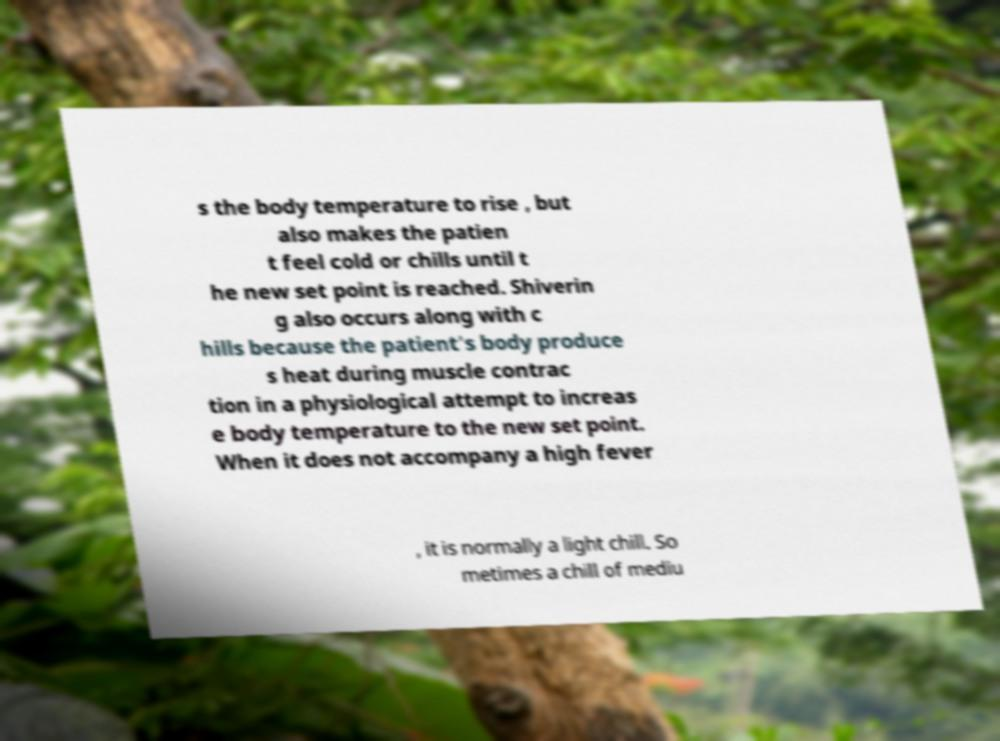Can you read and provide the text displayed in the image?This photo seems to have some interesting text. Can you extract and type it out for me? s the body temperature to rise , but also makes the patien t feel cold or chills until t he new set point is reached. Shiverin g also occurs along with c hills because the patient's body produce s heat during muscle contrac tion in a physiological attempt to increas e body temperature to the new set point. When it does not accompany a high fever , it is normally a light chill. So metimes a chill of mediu 